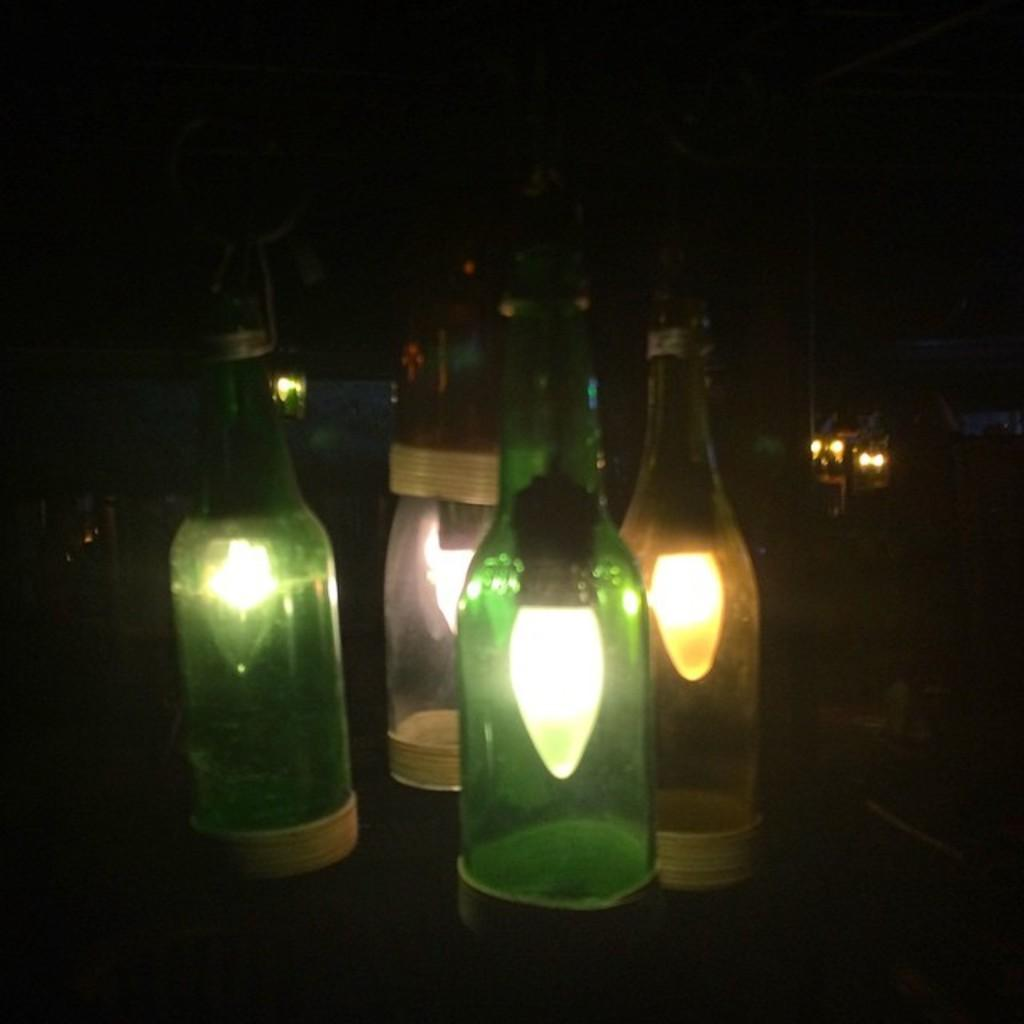What objects can be seen in the image? There are bottles in the image. What is inside the bottles? There are bulbs inside the bottles. What type of mitten is being used to attack the bulbs in the image? There is no mitten or attack present in the image; it only features bottles with bulbs inside. 